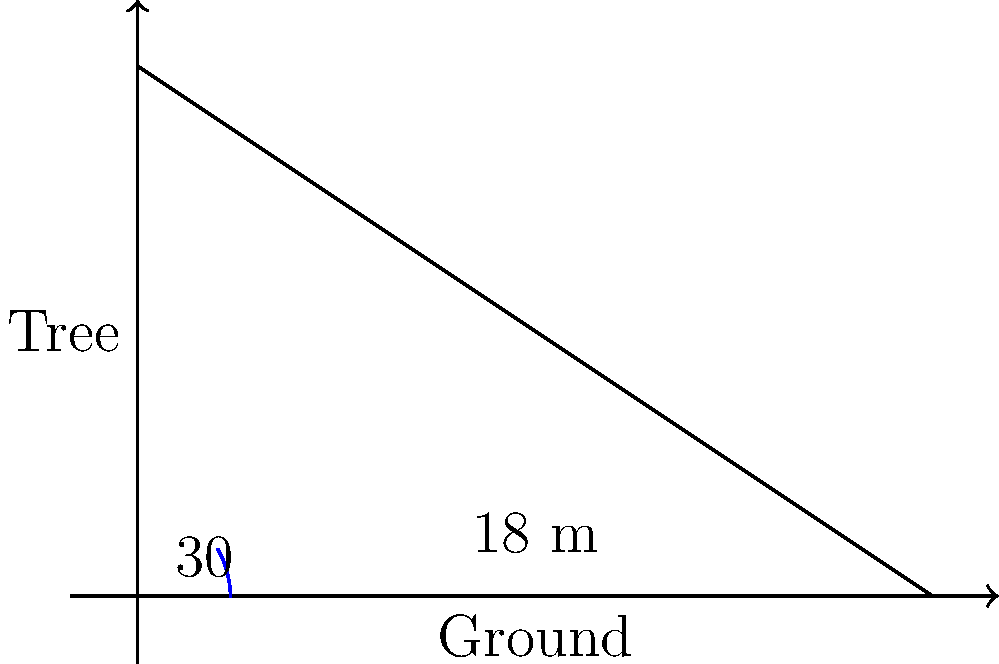As you're assessing a particularly tall tree for harvesting in your sustainably managed forest, you notice its shadow on the ground. The shadow is 18 meters long, and the angle of elevation from the end of the shadow to the top of the tree is 30°. How tall is this tree? Let's approach this step-by-step:

1) We can use the tangent function to solve this problem. The tangent of an angle in a right triangle is the ratio of the opposite side to the adjacent side.

2) In this case:
   - The angle is 30°
   - The adjacent side is the length of the shadow (18 m)
   - The opposite side is the height of the tree (what we're solving for)

3) Let's call the height of the tree $h$. We can write the equation:

   $$\tan(30°) = \frac{h}{18}$$

4) We know that $\tan(30°) = \frac{1}{\sqrt{3}}$, so we can rewrite the equation:

   $$\frac{1}{\sqrt{3}} = \frac{h}{18}$$

5) To solve for $h$, multiply both sides by 18:

   $$18 \cdot \frac{1}{\sqrt{3}} = h$$

6) Simplify:

   $$\frac{18}{\sqrt{3}} = h$$

7) To get a decimal approximation, we can use a calculator:

   $$h \approx 10.39$$

Therefore, the tree is approximately 10.39 meters tall.
Answer: $10.39$ meters 